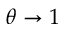Convert formula to latex. <formula><loc_0><loc_0><loc_500><loc_500>\theta \to 1</formula> 